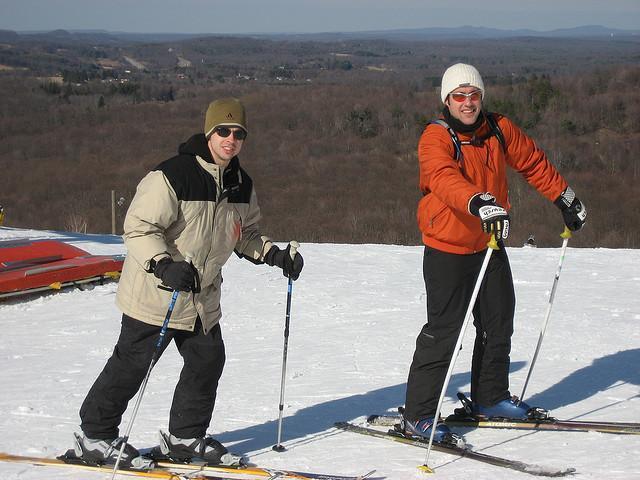How many people are completely visible in this picture?
Give a very brief answer. 2. How many people are in the picture?
Give a very brief answer. 2. How many decks does the bus have?
Give a very brief answer. 0. 